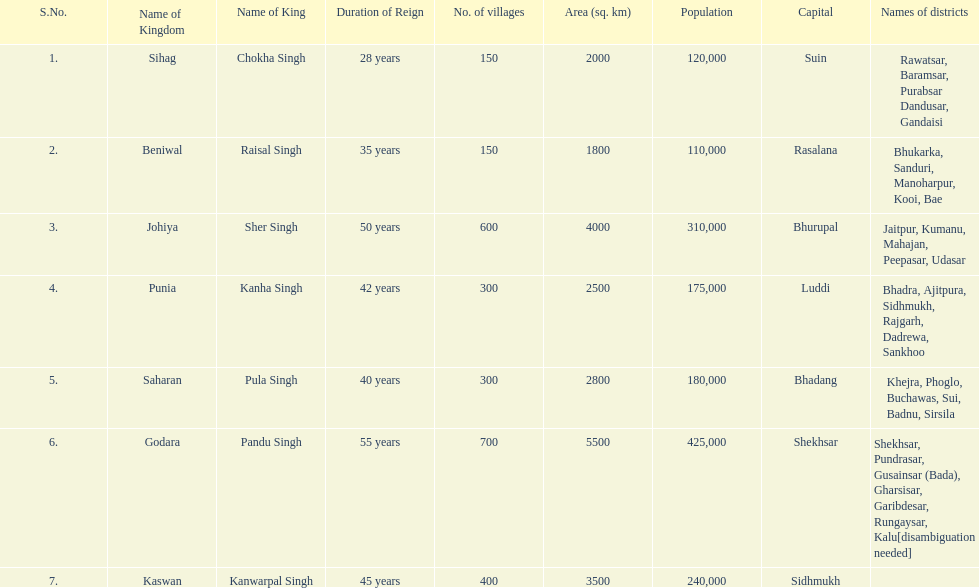How many kingdoms are listed? 7. 